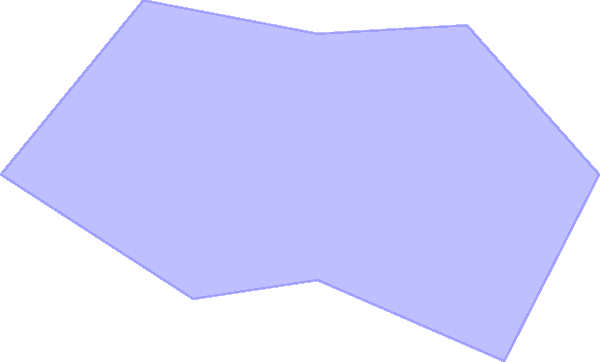In the polar graph representing server load distribution across multiple data centers, what is the total load difference between the most heavily loaded and least loaded data centers? Assume each concentric circle represents a 20% increment in server load. To solve this problem, we need to follow these steps:

1. Identify the most heavily loaded data center:
   - Examining the graph, we see the longest "spoke" at 180°, reaching the 90% mark.

2. Identify the least loaded data center:
   - The shortest "spoke" is at 270°, reaching the 30% mark.

3. Calculate the difference:
   - Most heavily loaded: 90%
   - Least loaded: 30%
   - Difference: $90\% - 30\% = 60\%$

Therefore, the total load difference between the most heavily loaded and least loaded data centers is 60%.

This analysis helps system analysts understand the load distribution across data centers, which is crucial for:
- Identifying potential bottlenecks
- Planning capacity upgrades
- Implementing load balancing strategies
- Ensuring optimal resource utilization across the enterprise infrastructure
Answer: 60% 